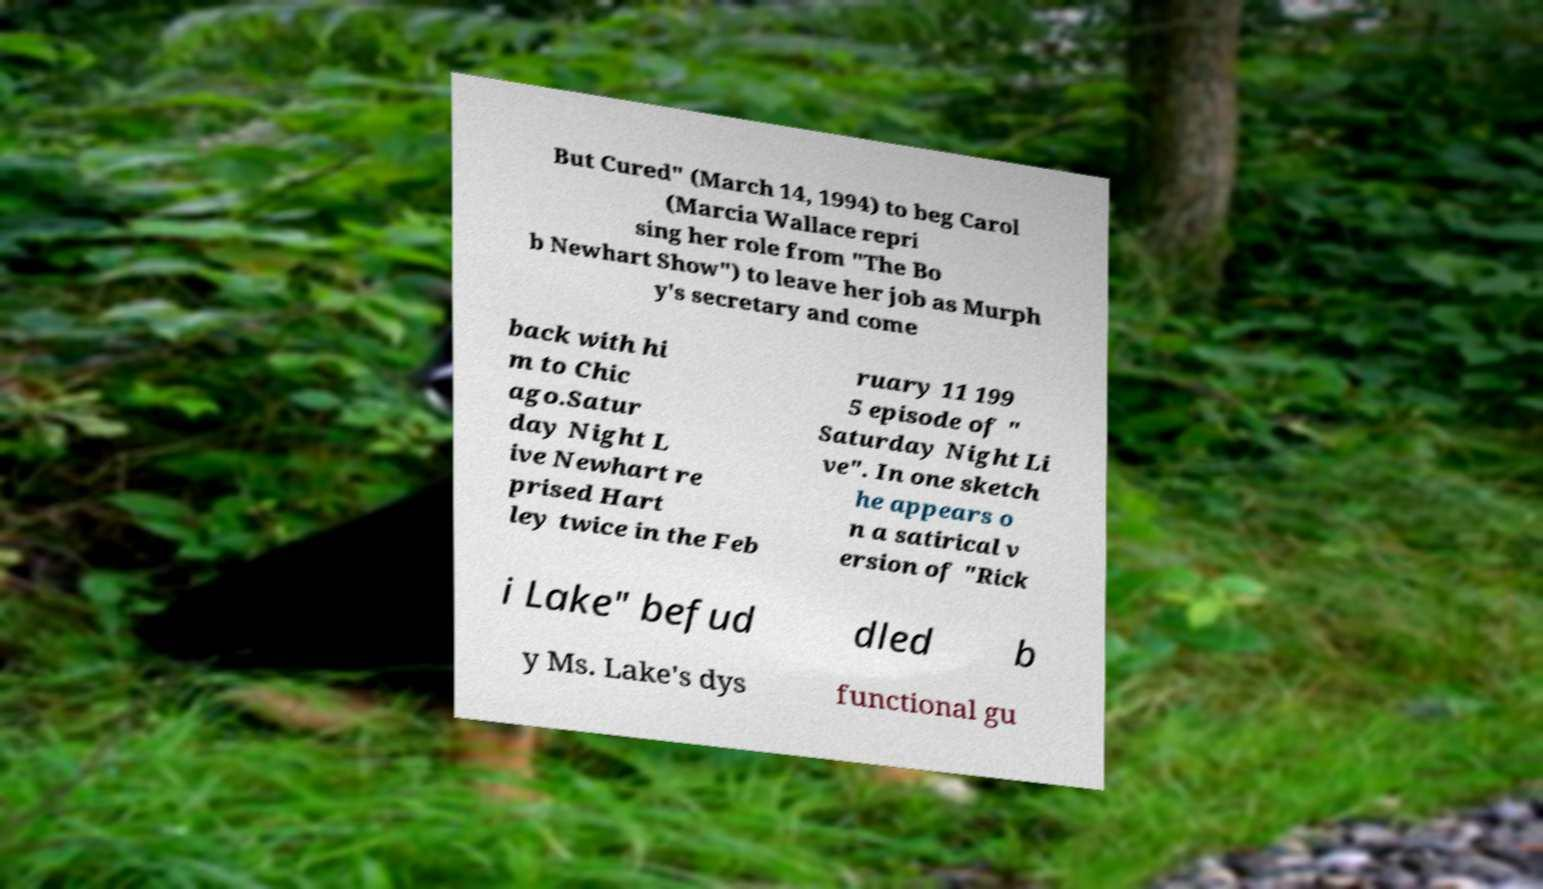Could you assist in decoding the text presented in this image and type it out clearly? But Cured" (March 14, 1994) to beg Carol (Marcia Wallace repri sing her role from "The Bo b Newhart Show") to leave her job as Murph y's secretary and come back with hi m to Chic ago.Satur day Night L ive Newhart re prised Hart ley twice in the Feb ruary 11 199 5 episode of " Saturday Night Li ve". In one sketch he appears o n a satirical v ersion of "Rick i Lake" befud dled b y Ms. Lake's dys functional gu 